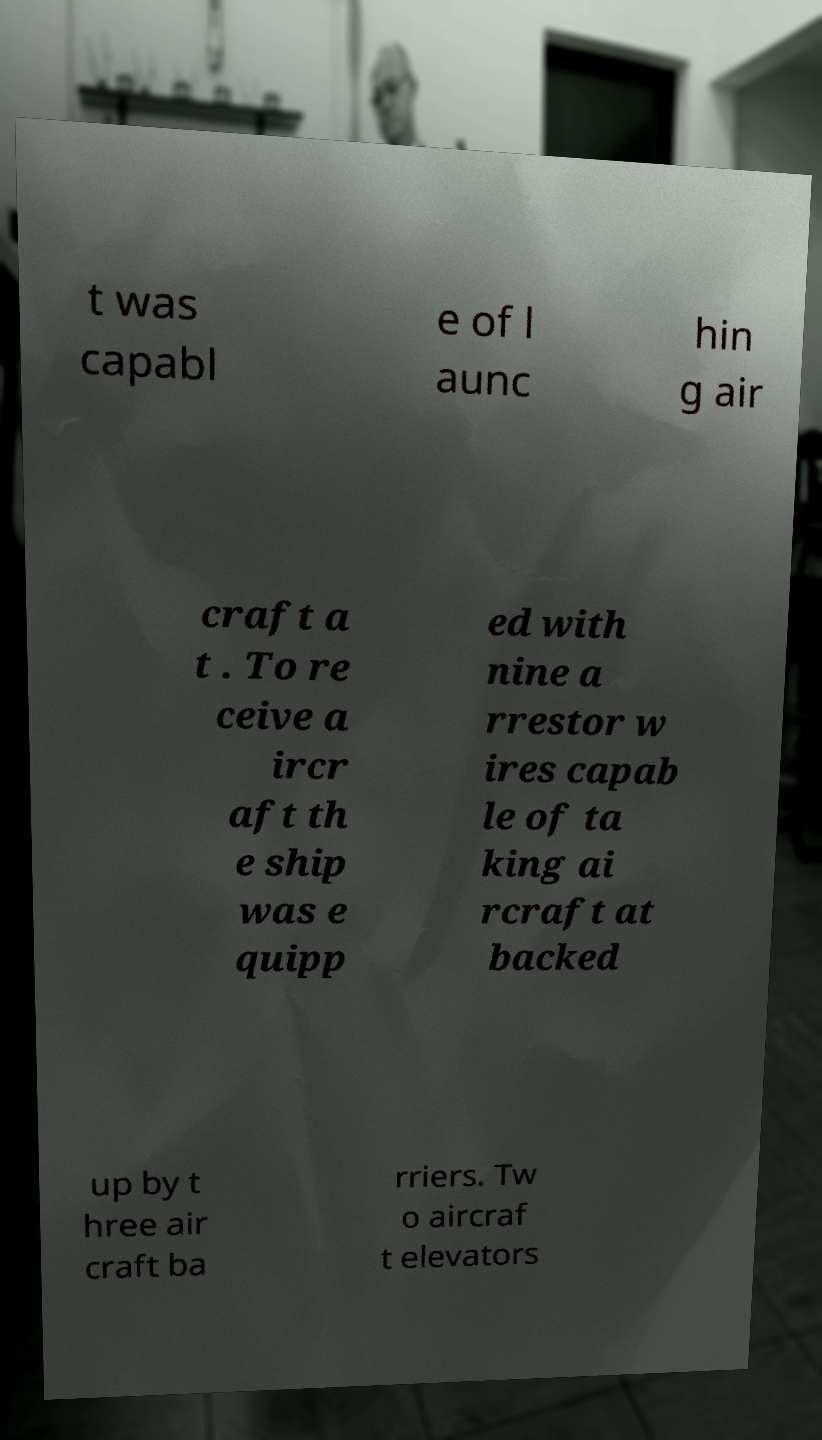Please read and relay the text visible in this image. What does it say? t was capabl e of l aunc hin g air craft a t . To re ceive a ircr aft th e ship was e quipp ed with nine a rrestor w ires capab le of ta king ai rcraft at backed up by t hree air craft ba rriers. Tw o aircraf t elevators 